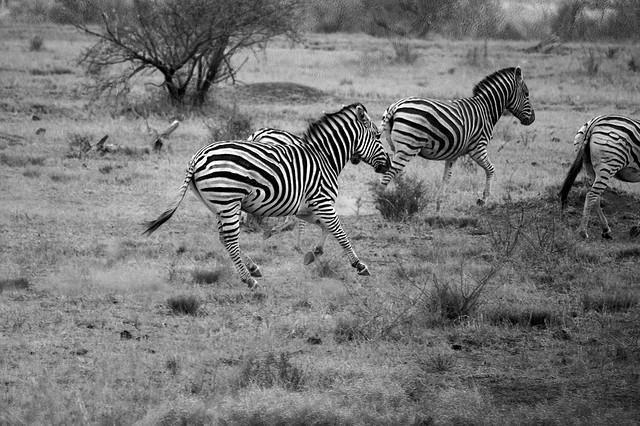How many zebras are running in the savannah area?
Choose the correct response and explain in the format: 'Answer: answer
Rationale: rationale.'
Options: Four, one, two, five. Answer: two.
Rationale: There are four zebras in the photo but only two of them are running. 